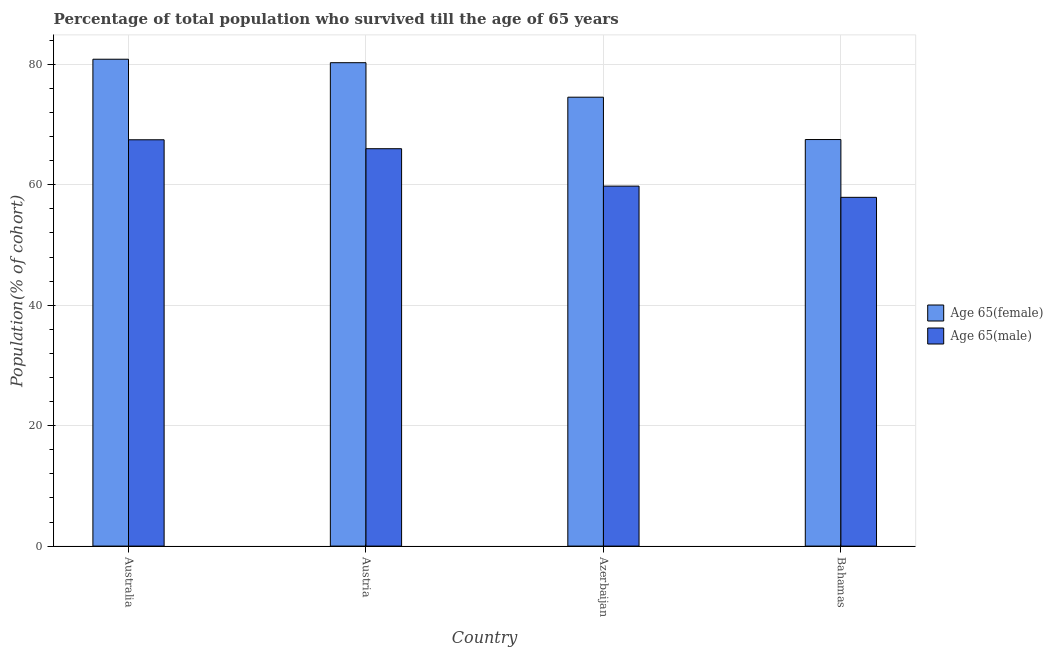How many different coloured bars are there?
Your answer should be compact. 2. Are the number of bars per tick equal to the number of legend labels?
Provide a short and direct response. Yes. How many bars are there on the 4th tick from the left?
Provide a succinct answer. 2. In how many cases, is the number of bars for a given country not equal to the number of legend labels?
Give a very brief answer. 0. What is the percentage of male population who survived till age of 65 in Austria?
Ensure brevity in your answer.  65.99. Across all countries, what is the maximum percentage of female population who survived till age of 65?
Offer a terse response. 80.85. Across all countries, what is the minimum percentage of female population who survived till age of 65?
Give a very brief answer. 67.51. In which country was the percentage of male population who survived till age of 65 minimum?
Your answer should be compact. Bahamas. What is the total percentage of female population who survived till age of 65 in the graph?
Your response must be concise. 303.18. What is the difference between the percentage of female population who survived till age of 65 in Australia and that in Bahamas?
Your response must be concise. 13.34. What is the difference between the percentage of female population who survived till age of 65 in Australia and the percentage of male population who survived till age of 65 in Austria?
Offer a terse response. 14.86. What is the average percentage of male population who survived till age of 65 per country?
Keep it short and to the point. 62.79. What is the difference between the percentage of female population who survived till age of 65 and percentage of male population who survived till age of 65 in Bahamas?
Keep it short and to the point. 9.6. What is the ratio of the percentage of male population who survived till age of 65 in Australia to that in Austria?
Your response must be concise. 1.02. Is the percentage of female population who survived till age of 65 in Azerbaijan less than that in Bahamas?
Offer a terse response. No. Is the difference between the percentage of male population who survived till age of 65 in Australia and Austria greater than the difference between the percentage of female population who survived till age of 65 in Australia and Austria?
Make the answer very short. Yes. What is the difference between the highest and the second highest percentage of male population who survived till age of 65?
Give a very brief answer. 1.49. What is the difference between the highest and the lowest percentage of male population who survived till age of 65?
Keep it short and to the point. 9.56. Is the sum of the percentage of female population who survived till age of 65 in Austria and Bahamas greater than the maximum percentage of male population who survived till age of 65 across all countries?
Keep it short and to the point. Yes. What does the 1st bar from the left in Austria represents?
Your answer should be very brief. Age 65(female). What does the 1st bar from the right in Azerbaijan represents?
Your answer should be very brief. Age 65(male). How many bars are there?
Your answer should be compact. 8. Are all the bars in the graph horizontal?
Your answer should be compact. No. Are the values on the major ticks of Y-axis written in scientific E-notation?
Give a very brief answer. No. Does the graph contain grids?
Keep it short and to the point. Yes. What is the title of the graph?
Offer a terse response. Percentage of total population who survived till the age of 65 years. What is the label or title of the Y-axis?
Make the answer very short. Population(% of cohort). What is the Population(% of cohort) in Age 65(female) in Australia?
Give a very brief answer. 80.85. What is the Population(% of cohort) in Age 65(male) in Australia?
Your answer should be very brief. 67.47. What is the Population(% of cohort) of Age 65(female) in Austria?
Make the answer very short. 80.27. What is the Population(% of cohort) of Age 65(male) in Austria?
Your response must be concise. 65.99. What is the Population(% of cohort) of Age 65(female) in Azerbaijan?
Offer a very short reply. 74.54. What is the Population(% of cohort) of Age 65(male) in Azerbaijan?
Your response must be concise. 59.78. What is the Population(% of cohort) in Age 65(female) in Bahamas?
Make the answer very short. 67.51. What is the Population(% of cohort) of Age 65(male) in Bahamas?
Your answer should be very brief. 57.91. Across all countries, what is the maximum Population(% of cohort) of Age 65(female)?
Give a very brief answer. 80.85. Across all countries, what is the maximum Population(% of cohort) of Age 65(male)?
Make the answer very short. 67.47. Across all countries, what is the minimum Population(% of cohort) in Age 65(female)?
Your response must be concise. 67.51. Across all countries, what is the minimum Population(% of cohort) in Age 65(male)?
Keep it short and to the point. 57.91. What is the total Population(% of cohort) in Age 65(female) in the graph?
Keep it short and to the point. 303.18. What is the total Population(% of cohort) in Age 65(male) in the graph?
Offer a very short reply. 251.16. What is the difference between the Population(% of cohort) in Age 65(female) in Australia and that in Austria?
Your answer should be compact. 0.58. What is the difference between the Population(% of cohort) of Age 65(male) in Australia and that in Austria?
Your response must be concise. 1.49. What is the difference between the Population(% of cohort) of Age 65(female) in Australia and that in Azerbaijan?
Ensure brevity in your answer.  6.31. What is the difference between the Population(% of cohort) in Age 65(male) in Australia and that in Azerbaijan?
Provide a succinct answer. 7.7. What is the difference between the Population(% of cohort) of Age 65(female) in Australia and that in Bahamas?
Ensure brevity in your answer.  13.34. What is the difference between the Population(% of cohort) in Age 65(male) in Australia and that in Bahamas?
Your answer should be very brief. 9.56. What is the difference between the Population(% of cohort) of Age 65(female) in Austria and that in Azerbaijan?
Offer a very short reply. 5.73. What is the difference between the Population(% of cohort) in Age 65(male) in Austria and that in Azerbaijan?
Your answer should be compact. 6.21. What is the difference between the Population(% of cohort) of Age 65(female) in Austria and that in Bahamas?
Provide a succinct answer. 12.76. What is the difference between the Population(% of cohort) in Age 65(male) in Austria and that in Bahamas?
Offer a very short reply. 8.07. What is the difference between the Population(% of cohort) in Age 65(female) in Azerbaijan and that in Bahamas?
Ensure brevity in your answer.  7.03. What is the difference between the Population(% of cohort) in Age 65(male) in Azerbaijan and that in Bahamas?
Your answer should be compact. 1.86. What is the difference between the Population(% of cohort) of Age 65(female) in Australia and the Population(% of cohort) of Age 65(male) in Austria?
Your answer should be compact. 14.86. What is the difference between the Population(% of cohort) of Age 65(female) in Australia and the Population(% of cohort) of Age 65(male) in Azerbaijan?
Provide a short and direct response. 21.07. What is the difference between the Population(% of cohort) of Age 65(female) in Australia and the Population(% of cohort) of Age 65(male) in Bahamas?
Offer a very short reply. 22.94. What is the difference between the Population(% of cohort) in Age 65(female) in Austria and the Population(% of cohort) in Age 65(male) in Azerbaijan?
Offer a very short reply. 20.5. What is the difference between the Population(% of cohort) in Age 65(female) in Austria and the Population(% of cohort) in Age 65(male) in Bahamas?
Keep it short and to the point. 22.36. What is the difference between the Population(% of cohort) of Age 65(female) in Azerbaijan and the Population(% of cohort) of Age 65(male) in Bahamas?
Your response must be concise. 16.63. What is the average Population(% of cohort) of Age 65(female) per country?
Offer a terse response. 75.8. What is the average Population(% of cohort) of Age 65(male) per country?
Provide a short and direct response. 62.79. What is the difference between the Population(% of cohort) of Age 65(female) and Population(% of cohort) of Age 65(male) in Australia?
Make the answer very short. 13.38. What is the difference between the Population(% of cohort) in Age 65(female) and Population(% of cohort) in Age 65(male) in Austria?
Offer a very short reply. 14.29. What is the difference between the Population(% of cohort) in Age 65(female) and Population(% of cohort) in Age 65(male) in Azerbaijan?
Provide a short and direct response. 14.76. What is the difference between the Population(% of cohort) in Age 65(female) and Population(% of cohort) in Age 65(male) in Bahamas?
Your answer should be compact. 9.6. What is the ratio of the Population(% of cohort) of Age 65(male) in Australia to that in Austria?
Ensure brevity in your answer.  1.02. What is the ratio of the Population(% of cohort) of Age 65(female) in Australia to that in Azerbaijan?
Offer a terse response. 1.08. What is the ratio of the Population(% of cohort) of Age 65(male) in Australia to that in Azerbaijan?
Provide a succinct answer. 1.13. What is the ratio of the Population(% of cohort) in Age 65(female) in Australia to that in Bahamas?
Your answer should be very brief. 1.2. What is the ratio of the Population(% of cohort) of Age 65(male) in Australia to that in Bahamas?
Provide a short and direct response. 1.17. What is the ratio of the Population(% of cohort) of Age 65(female) in Austria to that in Azerbaijan?
Ensure brevity in your answer.  1.08. What is the ratio of the Population(% of cohort) in Age 65(male) in Austria to that in Azerbaijan?
Your response must be concise. 1.1. What is the ratio of the Population(% of cohort) of Age 65(female) in Austria to that in Bahamas?
Your response must be concise. 1.19. What is the ratio of the Population(% of cohort) of Age 65(male) in Austria to that in Bahamas?
Provide a succinct answer. 1.14. What is the ratio of the Population(% of cohort) in Age 65(female) in Azerbaijan to that in Bahamas?
Make the answer very short. 1.1. What is the ratio of the Population(% of cohort) of Age 65(male) in Azerbaijan to that in Bahamas?
Ensure brevity in your answer.  1.03. What is the difference between the highest and the second highest Population(% of cohort) in Age 65(female)?
Give a very brief answer. 0.58. What is the difference between the highest and the second highest Population(% of cohort) in Age 65(male)?
Ensure brevity in your answer.  1.49. What is the difference between the highest and the lowest Population(% of cohort) in Age 65(female)?
Keep it short and to the point. 13.34. What is the difference between the highest and the lowest Population(% of cohort) of Age 65(male)?
Ensure brevity in your answer.  9.56. 